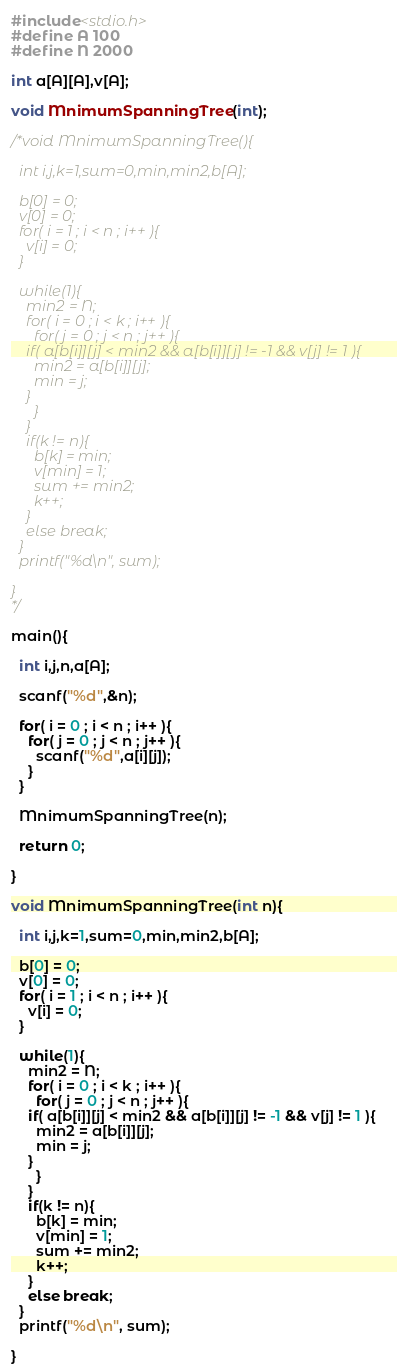Convert code to text. <code><loc_0><loc_0><loc_500><loc_500><_C_>#include<stdio.h>
#define A 100
#define N 2000

int a[A][A],v[A]; 

void MnimumSpanningTree(int);

/*void MnimumSpanningTree(){

  int i,j,k=1,sum=0,min,min2,b[A];

  b[0] = 0;
  v[0] = 0;
  for( i = 1 ; i < n ; i++ ){
    v[i] = 0;
  }

  while(1){
    min2 = N;
    for( i = 0 ; i < k ; i++ ){
      for( j = 0 ; j < n ; j++ ){
	if( a[b[i]][j] < min2 && a[b[i]][j] != -1 && v[j] != 1 ){
	  min2 = a[b[i]][j];
	  min = j;
	}
      }
    }
    if(k != n){
      b[k] = min;
      v[min] = 1;
      sum += min2;
      k++;
    }
    else break;
  }
  printf("%d\n", sum);

}
*/

main(){

  int i,j,n,a[A];

  scanf("%d",&n);

  for( i = 0 ; i < n ; i++ ){
    for( j = 0 ; j < n ; j++ ){
      scanf("%d",a[i][j]);
	}
  }
 
  MnimumSpanningTree(n);

  return 0;

}

void MnimumSpanningTree(int n){

  int i,j,k=1,sum=0,min,min2,b[A];

  b[0] = 0;
  v[0] = 0;
  for( i = 1 ; i < n ; i++ ){
    v[i] = 0;
  }

  while(1){
    min2 = N;
    for( i = 0 ; i < k ; i++ ){
      for( j = 0 ; j < n ; j++ ){
	if( a[b[i]][j] < min2 && a[b[i]][j] != -1 && v[j] != 1 ){
	  min2 = a[b[i]][j];
	  min = j;
	}
      }
    }
    if(k != n){
      b[k] = min;
      v[min] = 1;
      sum += min2;
      k++;
    }
    else break;
  }
  printf("%d\n", sum);

}</code> 